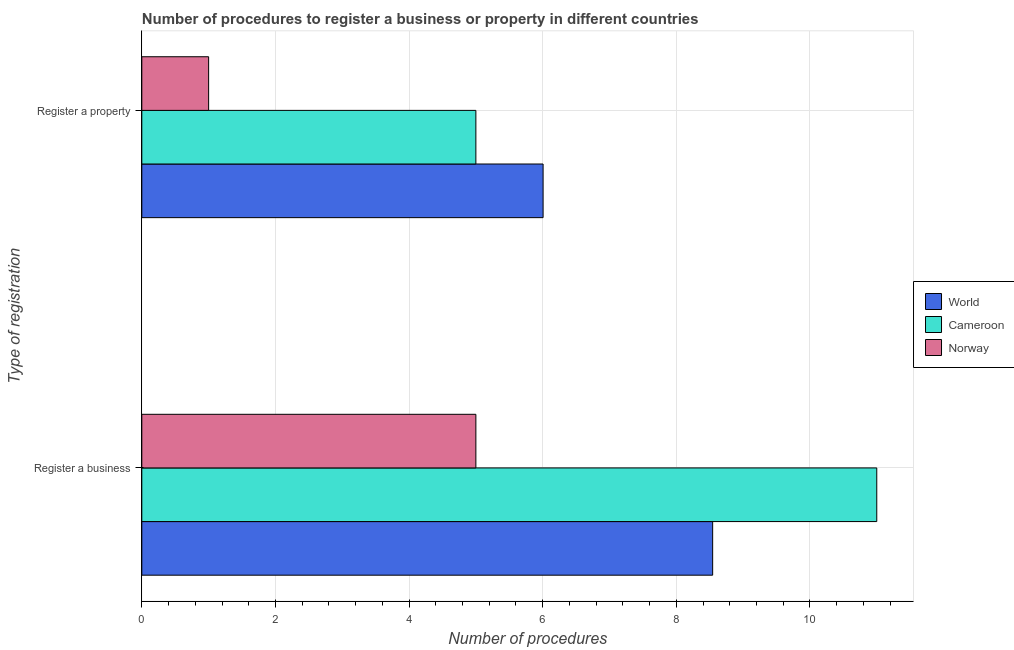How many bars are there on the 1st tick from the top?
Offer a very short reply. 3. What is the label of the 1st group of bars from the top?
Your answer should be compact. Register a property. What is the number of procedures to register a property in Norway?
Your response must be concise. 1. Across all countries, what is the minimum number of procedures to register a business?
Provide a short and direct response. 5. In which country was the number of procedures to register a business maximum?
Provide a short and direct response. Cameroon. In which country was the number of procedures to register a business minimum?
Offer a terse response. Norway. What is the total number of procedures to register a business in the graph?
Give a very brief answer. 24.54. What is the difference between the number of procedures to register a property in Cameroon and that in Norway?
Ensure brevity in your answer.  4. What is the difference between the number of procedures to register a business in World and the number of procedures to register a property in Norway?
Your response must be concise. 7.54. What is the average number of procedures to register a property per country?
Make the answer very short. 4. What is the difference between the number of procedures to register a property and number of procedures to register a business in Norway?
Your answer should be very brief. -4. What is the ratio of the number of procedures to register a business in Norway to that in Cameroon?
Offer a very short reply. 0.45. Is the number of procedures to register a property in Norway less than that in World?
Keep it short and to the point. Yes. In how many countries, is the number of procedures to register a property greater than the average number of procedures to register a property taken over all countries?
Your answer should be very brief. 2. What does the 2nd bar from the top in Register a property represents?
Provide a short and direct response. Cameroon. How many bars are there?
Your answer should be very brief. 6. What is the difference between two consecutive major ticks on the X-axis?
Make the answer very short. 2. Does the graph contain grids?
Ensure brevity in your answer.  Yes. How many legend labels are there?
Your response must be concise. 3. What is the title of the graph?
Your answer should be compact. Number of procedures to register a business or property in different countries. Does "Ghana" appear as one of the legend labels in the graph?
Your response must be concise. No. What is the label or title of the X-axis?
Offer a very short reply. Number of procedures. What is the label or title of the Y-axis?
Give a very brief answer. Type of registration. What is the Number of procedures of World in Register a business?
Offer a very short reply. 8.54. What is the Number of procedures in Cameroon in Register a business?
Your answer should be very brief. 11. What is the Number of procedures in World in Register a property?
Provide a short and direct response. 6.01. What is the Number of procedures in Norway in Register a property?
Your response must be concise. 1. Across all Type of registration, what is the maximum Number of procedures of World?
Ensure brevity in your answer.  8.54. Across all Type of registration, what is the maximum Number of procedures of Norway?
Your answer should be very brief. 5. Across all Type of registration, what is the minimum Number of procedures in World?
Provide a short and direct response. 6.01. Across all Type of registration, what is the minimum Number of procedures of Cameroon?
Ensure brevity in your answer.  5. Across all Type of registration, what is the minimum Number of procedures in Norway?
Your answer should be very brief. 1. What is the total Number of procedures in World in the graph?
Make the answer very short. 14.55. What is the total Number of procedures in Cameroon in the graph?
Ensure brevity in your answer.  16. What is the difference between the Number of procedures in World in Register a business and that in Register a property?
Offer a terse response. 2.54. What is the difference between the Number of procedures in World in Register a business and the Number of procedures in Cameroon in Register a property?
Provide a succinct answer. 3.54. What is the difference between the Number of procedures in World in Register a business and the Number of procedures in Norway in Register a property?
Offer a very short reply. 7.54. What is the difference between the Number of procedures of Cameroon in Register a business and the Number of procedures of Norway in Register a property?
Offer a very short reply. 10. What is the average Number of procedures of World per Type of registration?
Your response must be concise. 7.27. What is the average Number of procedures in Norway per Type of registration?
Your answer should be very brief. 3. What is the difference between the Number of procedures of World and Number of procedures of Cameroon in Register a business?
Give a very brief answer. -2.46. What is the difference between the Number of procedures in World and Number of procedures in Norway in Register a business?
Provide a short and direct response. 3.54. What is the difference between the Number of procedures in World and Number of procedures in Norway in Register a property?
Your response must be concise. 5.01. What is the difference between the Number of procedures of Cameroon and Number of procedures of Norway in Register a property?
Ensure brevity in your answer.  4. What is the ratio of the Number of procedures in World in Register a business to that in Register a property?
Provide a succinct answer. 1.42. What is the ratio of the Number of procedures of Cameroon in Register a business to that in Register a property?
Your answer should be very brief. 2.2. What is the difference between the highest and the second highest Number of procedures of World?
Keep it short and to the point. 2.54. What is the difference between the highest and the lowest Number of procedures of World?
Your response must be concise. 2.54. What is the difference between the highest and the lowest Number of procedures in Norway?
Make the answer very short. 4. 